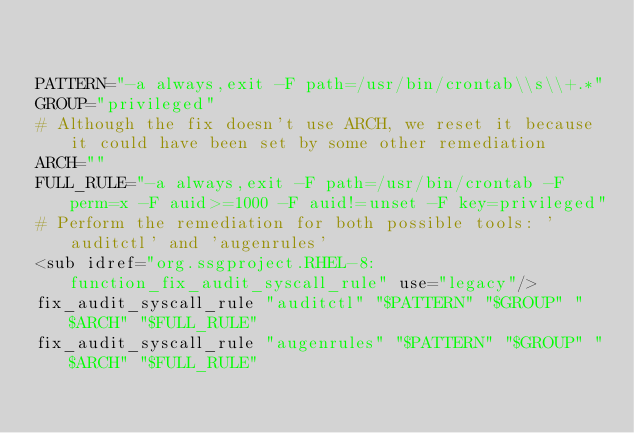Convert code to text. <code><loc_0><loc_0><loc_500><loc_500><_Bash_>

PATTERN="-a always,exit -F path=/usr/bin/crontab\\s\\+.*"
GROUP="privileged"
# Although the fix doesn't use ARCH, we reset it because it could have been set by some other remediation
ARCH=""
FULL_RULE="-a always,exit -F path=/usr/bin/crontab -F perm=x -F auid>=1000 -F auid!=unset -F key=privileged"
# Perform the remediation for both possible tools: 'auditctl' and 'augenrules'
<sub idref="org.ssgproject.RHEL-8:function_fix_audit_syscall_rule" use="legacy"/>
fix_audit_syscall_rule "auditctl" "$PATTERN" "$GROUP" "$ARCH" "$FULL_RULE"
fix_audit_syscall_rule "augenrules" "$PATTERN" "$GROUP" "$ARCH" "$FULL_RULE"

                
</code> 